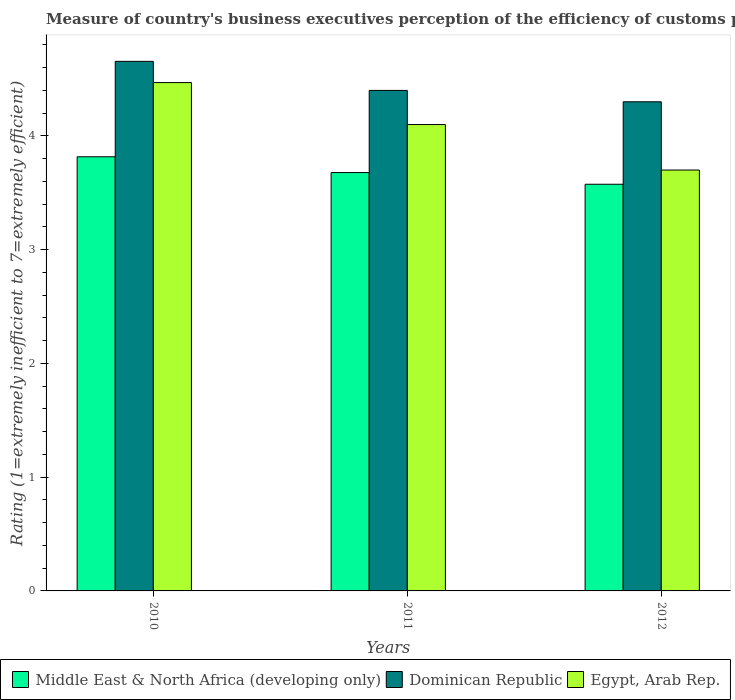How many different coloured bars are there?
Give a very brief answer. 3. Are the number of bars per tick equal to the number of legend labels?
Your answer should be compact. Yes. How many bars are there on the 2nd tick from the right?
Ensure brevity in your answer.  3. In how many cases, is the number of bars for a given year not equal to the number of legend labels?
Provide a short and direct response. 0. What is the rating of the efficiency of customs procedure in Dominican Republic in 2011?
Your response must be concise. 4.4. Across all years, what is the maximum rating of the efficiency of customs procedure in Middle East & North Africa (developing only)?
Offer a very short reply. 3.82. Across all years, what is the minimum rating of the efficiency of customs procedure in Middle East & North Africa (developing only)?
Your response must be concise. 3.58. In which year was the rating of the efficiency of customs procedure in Dominican Republic maximum?
Make the answer very short. 2010. In which year was the rating of the efficiency of customs procedure in Egypt, Arab Rep. minimum?
Your answer should be compact. 2012. What is the total rating of the efficiency of customs procedure in Middle East & North Africa (developing only) in the graph?
Your answer should be very brief. 11.07. What is the difference between the rating of the efficiency of customs procedure in Egypt, Arab Rep. in 2011 and that in 2012?
Offer a terse response. 0.4. What is the difference between the rating of the efficiency of customs procedure in Middle East & North Africa (developing only) in 2010 and the rating of the efficiency of customs procedure in Dominican Republic in 2012?
Your answer should be compact. -0.48. What is the average rating of the efficiency of customs procedure in Dominican Republic per year?
Offer a very short reply. 4.45. In the year 2010, what is the difference between the rating of the efficiency of customs procedure in Egypt, Arab Rep. and rating of the efficiency of customs procedure in Dominican Republic?
Provide a succinct answer. -0.19. In how many years, is the rating of the efficiency of customs procedure in Dominican Republic greater than 2.2?
Offer a very short reply. 3. What is the ratio of the rating of the efficiency of customs procedure in Middle East & North Africa (developing only) in 2010 to that in 2011?
Ensure brevity in your answer.  1.04. Is the rating of the efficiency of customs procedure in Egypt, Arab Rep. in 2010 less than that in 2011?
Keep it short and to the point. No. What is the difference between the highest and the second highest rating of the efficiency of customs procedure in Middle East & North Africa (developing only)?
Offer a very short reply. 0.14. What is the difference between the highest and the lowest rating of the efficiency of customs procedure in Dominican Republic?
Offer a very short reply. 0.36. What does the 2nd bar from the left in 2011 represents?
Provide a succinct answer. Dominican Republic. What does the 3rd bar from the right in 2012 represents?
Your response must be concise. Middle East & North Africa (developing only). Are all the bars in the graph horizontal?
Your response must be concise. No. What is the difference between two consecutive major ticks on the Y-axis?
Provide a short and direct response. 1. Are the values on the major ticks of Y-axis written in scientific E-notation?
Provide a succinct answer. No. Does the graph contain any zero values?
Your answer should be very brief. No. How many legend labels are there?
Give a very brief answer. 3. How are the legend labels stacked?
Ensure brevity in your answer.  Horizontal. What is the title of the graph?
Give a very brief answer. Measure of country's business executives perception of the efficiency of customs procedures. What is the label or title of the X-axis?
Your response must be concise. Years. What is the label or title of the Y-axis?
Keep it short and to the point. Rating (1=extremely inefficient to 7=extremely efficient). What is the Rating (1=extremely inefficient to 7=extremely efficient) of Middle East & North Africa (developing only) in 2010?
Offer a terse response. 3.82. What is the Rating (1=extremely inefficient to 7=extremely efficient) in Dominican Republic in 2010?
Offer a very short reply. 4.66. What is the Rating (1=extremely inefficient to 7=extremely efficient) of Egypt, Arab Rep. in 2010?
Your answer should be compact. 4.47. What is the Rating (1=extremely inefficient to 7=extremely efficient) of Middle East & North Africa (developing only) in 2011?
Give a very brief answer. 3.68. What is the Rating (1=extremely inefficient to 7=extremely efficient) of Egypt, Arab Rep. in 2011?
Provide a succinct answer. 4.1. What is the Rating (1=extremely inefficient to 7=extremely efficient) of Middle East & North Africa (developing only) in 2012?
Make the answer very short. 3.58. What is the Rating (1=extremely inefficient to 7=extremely efficient) of Egypt, Arab Rep. in 2012?
Your answer should be compact. 3.7. Across all years, what is the maximum Rating (1=extremely inefficient to 7=extremely efficient) in Middle East & North Africa (developing only)?
Offer a very short reply. 3.82. Across all years, what is the maximum Rating (1=extremely inefficient to 7=extremely efficient) in Dominican Republic?
Your answer should be very brief. 4.66. Across all years, what is the maximum Rating (1=extremely inefficient to 7=extremely efficient) in Egypt, Arab Rep.?
Ensure brevity in your answer.  4.47. Across all years, what is the minimum Rating (1=extremely inefficient to 7=extremely efficient) in Middle East & North Africa (developing only)?
Ensure brevity in your answer.  3.58. Across all years, what is the minimum Rating (1=extremely inefficient to 7=extremely efficient) of Dominican Republic?
Make the answer very short. 4.3. What is the total Rating (1=extremely inefficient to 7=extremely efficient) in Middle East & North Africa (developing only) in the graph?
Offer a very short reply. 11.07. What is the total Rating (1=extremely inefficient to 7=extremely efficient) of Dominican Republic in the graph?
Keep it short and to the point. 13.36. What is the total Rating (1=extremely inefficient to 7=extremely efficient) of Egypt, Arab Rep. in the graph?
Your response must be concise. 12.27. What is the difference between the Rating (1=extremely inefficient to 7=extremely efficient) of Middle East & North Africa (developing only) in 2010 and that in 2011?
Your answer should be very brief. 0.14. What is the difference between the Rating (1=extremely inefficient to 7=extremely efficient) of Dominican Republic in 2010 and that in 2011?
Keep it short and to the point. 0.26. What is the difference between the Rating (1=extremely inefficient to 7=extremely efficient) of Egypt, Arab Rep. in 2010 and that in 2011?
Your answer should be very brief. 0.37. What is the difference between the Rating (1=extremely inefficient to 7=extremely efficient) in Middle East & North Africa (developing only) in 2010 and that in 2012?
Make the answer very short. 0.24. What is the difference between the Rating (1=extremely inefficient to 7=extremely efficient) of Dominican Republic in 2010 and that in 2012?
Your answer should be very brief. 0.36. What is the difference between the Rating (1=extremely inefficient to 7=extremely efficient) of Egypt, Arab Rep. in 2010 and that in 2012?
Provide a short and direct response. 0.77. What is the difference between the Rating (1=extremely inefficient to 7=extremely efficient) in Middle East & North Africa (developing only) in 2011 and that in 2012?
Ensure brevity in your answer.  0.1. What is the difference between the Rating (1=extremely inefficient to 7=extremely efficient) in Middle East & North Africa (developing only) in 2010 and the Rating (1=extremely inefficient to 7=extremely efficient) in Dominican Republic in 2011?
Provide a succinct answer. -0.58. What is the difference between the Rating (1=extremely inefficient to 7=extremely efficient) in Middle East & North Africa (developing only) in 2010 and the Rating (1=extremely inefficient to 7=extremely efficient) in Egypt, Arab Rep. in 2011?
Ensure brevity in your answer.  -0.28. What is the difference between the Rating (1=extremely inefficient to 7=extremely efficient) of Dominican Republic in 2010 and the Rating (1=extremely inefficient to 7=extremely efficient) of Egypt, Arab Rep. in 2011?
Your answer should be compact. 0.56. What is the difference between the Rating (1=extremely inefficient to 7=extremely efficient) in Middle East & North Africa (developing only) in 2010 and the Rating (1=extremely inefficient to 7=extremely efficient) in Dominican Republic in 2012?
Your response must be concise. -0.48. What is the difference between the Rating (1=extremely inefficient to 7=extremely efficient) in Middle East & North Africa (developing only) in 2010 and the Rating (1=extremely inefficient to 7=extremely efficient) in Egypt, Arab Rep. in 2012?
Make the answer very short. 0.12. What is the difference between the Rating (1=extremely inefficient to 7=extremely efficient) of Dominican Republic in 2010 and the Rating (1=extremely inefficient to 7=extremely efficient) of Egypt, Arab Rep. in 2012?
Your answer should be very brief. 0.96. What is the difference between the Rating (1=extremely inefficient to 7=extremely efficient) of Middle East & North Africa (developing only) in 2011 and the Rating (1=extremely inefficient to 7=extremely efficient) of Dominican Republic in 2012?
Provide a succinct answer. -0.62. What is the difference between the Rating (1=extremely inefficient to 7=extremely efficient) of Middle East & North Africa (developing only) in 2011 and the Rating (1=extremely inefficient to 7=extremely efficient) of Egypt, Arab Rep. in 2012?
Ensure brevity in your answer.  -0.02. What is the difference between the Rating (1=extremely inefficient to 7=extremely efficient) of Dominican Republic in 2011 and the Rating (1=extremely inefficient to 7=extremely efficient) of Egypt, Arab Rep. in 2012?
Offer a terse response. 0.7. What is the average Rating (1=extremely inefficient to 7=extremely efficient) in Middle East & North Africa (developing only) per year?
Keep it short and to the point. 3.69. What is the average Rating (1=extremely inefficient to 7=extremely efficient) of Dominican Republic per year?
Make the answer very short. 4.45. What is the average Rating (1=extremely inefficient to 7=extremely efficient) in Egypt, Arab Rep. per year?
Offer a terse response. 4.09. In the year 2010, what is the difference between the Rating (1=extremely inefficient to 7=extremely efficient) in Middle East & North Africa (developing only) and Rating (1=extremely inefficient to 7=extremely efficient) in Dominican Republic?
Make the answer very short. -0.84. In the year 2010, what is the difference between the Rating (1=extremely inefficient to 7=extremely efficient) of Middle East & North Africa (developing only) and Rating (1=extremely inefficient to 7=extremely efficient) of Egypt, Arab Rep.?
Your answer should be very brief. -0.65. In the year 2010, what is the difference between the Rating (1=extremely inefficient to 7=extremely efficient) in Dominican Republic and Rating (1=extremely inefficient to 7=extremely efficient) in Egypt, Arab Rep.?
Ensure brevity in your answer.  0.19. In the year 2011, what is the difference between the Rating (1=extremely inefficient to 7=extremely efficient) of Middle East & North Africa (developing only) and Rating (1=extremely inefficient to 7=extremely efficient) of Dominican Republic?
Provide a short and direct response. -0.72. In the year 2011, what is the difference between the Rating (1=extremely inefficient to 7=extremely efficient) in Middle East & North Africa (developing only) and Rating (1=extremely inefficient to 7=extremely efficient) in Egypt, Arab Rep.?
Make the answer very short. -0.42. In the year 2011, what is the difference between the Rating (1=extremely inefficient to 7=extremely efficient) of Dominican Republic and Rating (1=extremely inefficient to 7=extremely efficient) of Egypt, Arab Rep.?
Keep it short and to the point. 0.3. In the year 2012, what is the difference between the Rating (1=extremely inefficient to 7=extremely efficient) of Middle East & North Africa (developing only) and Rating (1=extremely inefficient to 7=extremely efficient) of Dominican Republic?
Ensure brevity in your answer.  -0.72. In the year 2012, what is the difference between the Rating (1=extremely inefficient to 7=extremely efficient) in Middle East & North Africa (developing only) and Rating (1=extremely inefficient to 7=extremely efficient) in Egypt, Arab Rep.?
Your answer should be compact. -0.12. In the year 2012, what is the difference between the Rating (1=extremely inefficient to 7=extremely efficient) in Dominican Republic and Rating (1=extremely inefficient to 7=extremely efficient) in Egypt, Arab Rep.?
Your answer should be very brief. 0.6. What is the ratio of the Rating (1=extremely inefficient to 7=extremely efficient) of Middle East & North Africa (developing only) in 2010 to that in 2011?
Offer a terse response. 1.04. What is the ratio of the Rating (1=extremely inefficient to 7=extremely efficient) in Dominican Republic in 2010 to that in 2011?
Make the answer very short. 1.06. What is the ratio of the Rating (1=extremely inefficient to 7=extremely efficient) in Egypt, Arab Rep. in 2010 to that in 2011?
Offer a terse response. 1.09. What is the ratio of the Rating (1=extremely inefficient to 7=extremely efficient) in Middle East & North Africa (developing only) in 2010 to that in 2012?
Give a very brief answer. 1.07. What is the ratio of the Rating (1=extremely inefficient to 7=extremely efficient) in Dominican Republic in 2010 to that in 2012?
Give a very brief answer. 1.08. What is the ratio of the Rating (1=extremely inefficient to 7=extremely efficient) of Egypt, Arab Rep. in 2010 to that in 2012?
Your response must be concise. 1.21. What is the ratio of the Rating (1=extremely inefficient to 7=extremely efficient) in Middle East & North Africa (developing only) in 2011 to that in 2012?
Give a very brief answer. 1.03. What is the ratio of the Rating (1=extremely inefficient to 7=extremely efficient) of Dominican Republic in 2011 to that in 2012?
Provide a short and direct response. 1.02. What is the ratio of the Rating (1=extremely inefficient to 7=extremely efficient) in Egypt, Arab Rep. in 2011 to that in 2012?
Keep it short and to the point. 1.11. What is the difference between the highest and the second highest Rating (1=extremely inefficient to 7=extremely efficient) in Middle East & North Africa (developing only)?
Give a very brief answer. 0.14. What is the difference between the highest and the second highest Rating (1=extremely inefficient to 7=extremely efficient) of Dominican Republic?
Keep it short and to the point. 0.26. What is the difference between the highest and the second highest Rating (1=extremely inefficient to 7=extremely efficient) in Egypt, Arab Rep.?
Make the answer very short. 0.37. What is the difference between the highest and the lowest Rating (1=extremely inefficient to 7=extremely efficient) in Middle East & North Africa (developing only)?
Keep it short and to the point. 0.24. What is the difference between the highest and the lowest Rating (1=extremely inefficient to 7=extremely efficient) in Dominican Republic?
Your response must be concise. 0.36. What is the difference between the highest and the lowest Rating (1=extremely inefficient to 7=extremely efficient) in Egypt, Arab Rep.?
Your response must be concise. 0.77. 